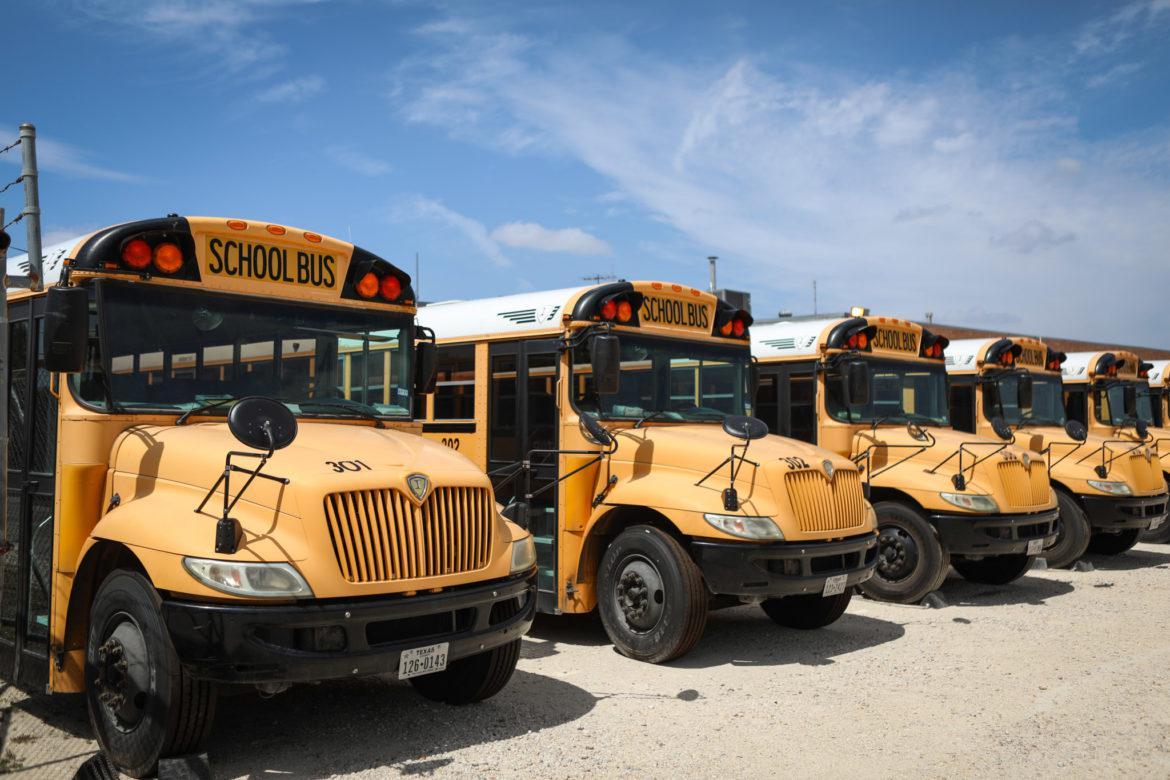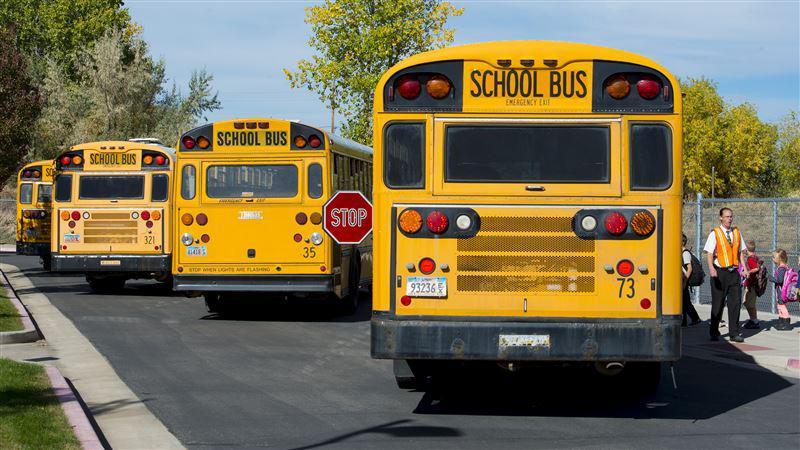The first image is the image on the left, the second image is the image on the right. Analyze the images presented: Is the assertion "An emergency is being dealt with right next to a school bus in one of the pictures." valid? Answer yes or no. No. The first image is the image on the left, the second image is the image on the right. Considering the images on both sides, is "The image on the right shows the back end of at least one bus." valid? Answer yes or no. Yes. 